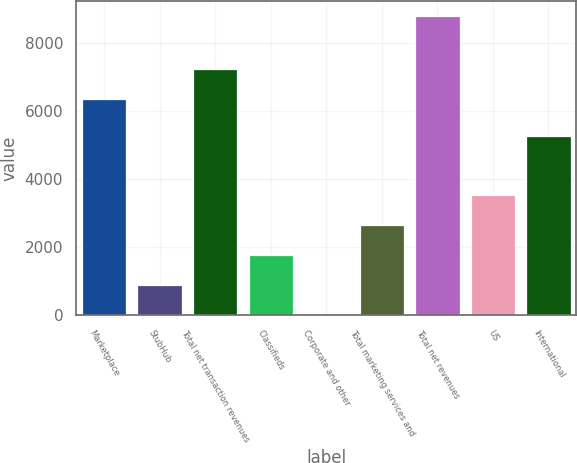Convert chart to OTSL. <chart><loc_0><loc_0><loc_500><loc_500><bar_chart><fcel>Marketplace<fcel>StubHub<fcel>Total net transaction revenues<fcel>Classifieds<fcel>Corporate and other<fcel>Total marketing services and<fcel>Total net revenues<fcel>US<fcel>International<nl><fcel>6351<fcel>887.1<fcel>7229.1<fcel>1765.2<fcel>9<fcel>2643.3<fcel>8790<fcel>3525<fcel>5265<nl></chart> 